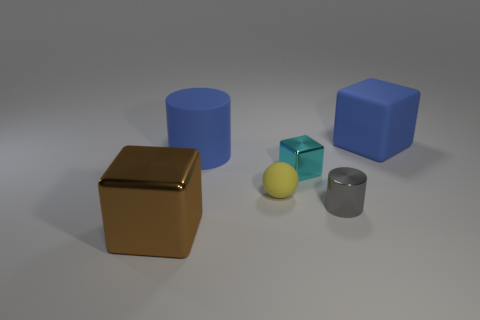Add 3 small green spheres. How many objects exist? 9 Subtract all cylinders. How many objects are left? 4 Add 1 brown metal objects. How many brown metal objects are left? 2 Add 5 large blue spheres. How many large blue spheres exist? 5 Subtract 0 green spheres. How many objects are left? 6 Subtract all small gray shiny cylinders. Subtract all tiny cyan objects. How many objects are left? 4 